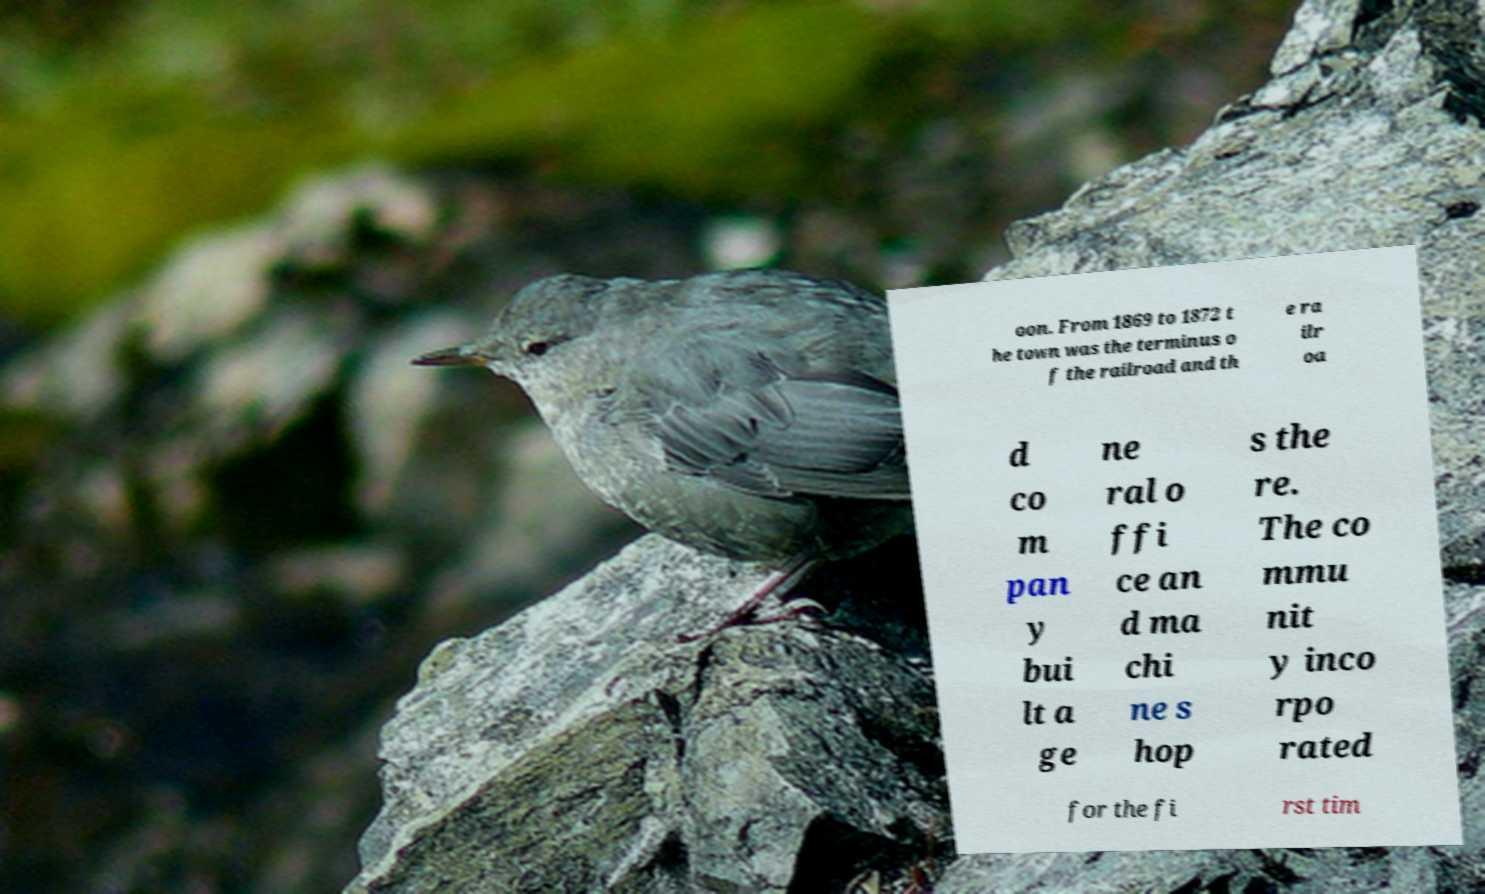What messages or text are displayed in this image? I need them in a readable, typed format. oon. From 1869 to 1872 t he town was the terminus o f the railroad and th e ra ilr oa d co m pan y bui lt a ge ne ral o ffi ce an d ma chi ne s hop s the re. The co mmu nit y inco rpo rated for the fi rst tim 